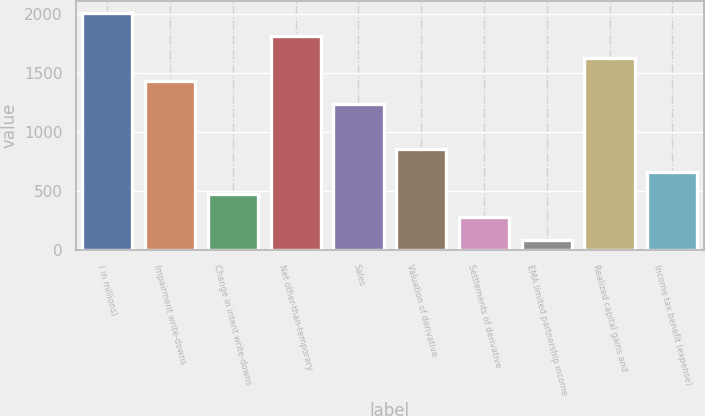<chart> <loc_0><loc_0><loc_500><loc_500><bar_chart><fcel>( in millions)<fcel>Impairment write-downs<fcel>Change in intent write-downs<fcel>Net other-than-temporary<fcel>Sales<fcel>Valuation of derivative<fcel>Settlements of derivative<fcel>EMA limited partnership income<fcel>Realized capital gains and<fcel>Income tax benefit (expense)<nl><fcel>2010<fcel>1433.7<fcel>473.2<fcel>1817.9<fcel>1241.6<fcel>857.4<fcel>281.1<fcel>89<fcel>1625.8<fcel>665.3<nl></chart> 